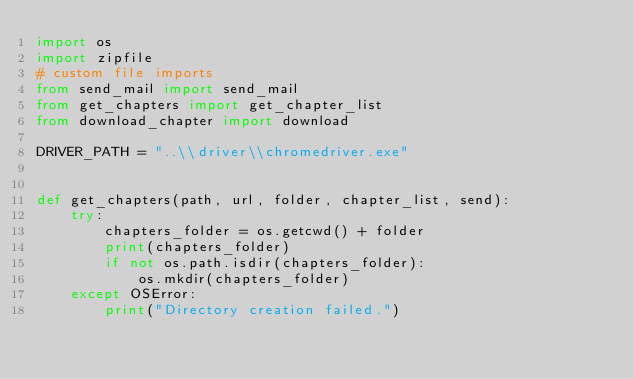<code> <loc_0><loc_0><loc_500><loc_500><_Python_>import os
import zipfile
# custom file imports
from send_mail import send_mail
from get_chapters import get_chapter_list
from download_chapter import download

DRIVER_PATH = "..\\driver\\chromedriver.exe"


def get_chapters(path, url, folder, chapter_list, send):
    try:
        chapters_folder = os.getcwd() + folder
        print(chapters_folder)
        if not os.path.isdir(chapters_folder):
            os.mkdir(chapters_folder)
    except OSError:
        print("Directory creation failed.")</code> 